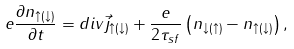<formula> <loc_0><loc_0><loc_500><loc_500>e \frac { \partial n _ { \uparrow ( \downarrow ) } } { \partial t } = d i v \vec { j } _ { \uparrow ( \downarrow ) } + \frac { e } { 2 \tau _ { s f } } \left ( n _ { \downarrow ( \uparrow ) } - n _ { \uparrow ( \downarrow ) } \right ) ,</formula> 